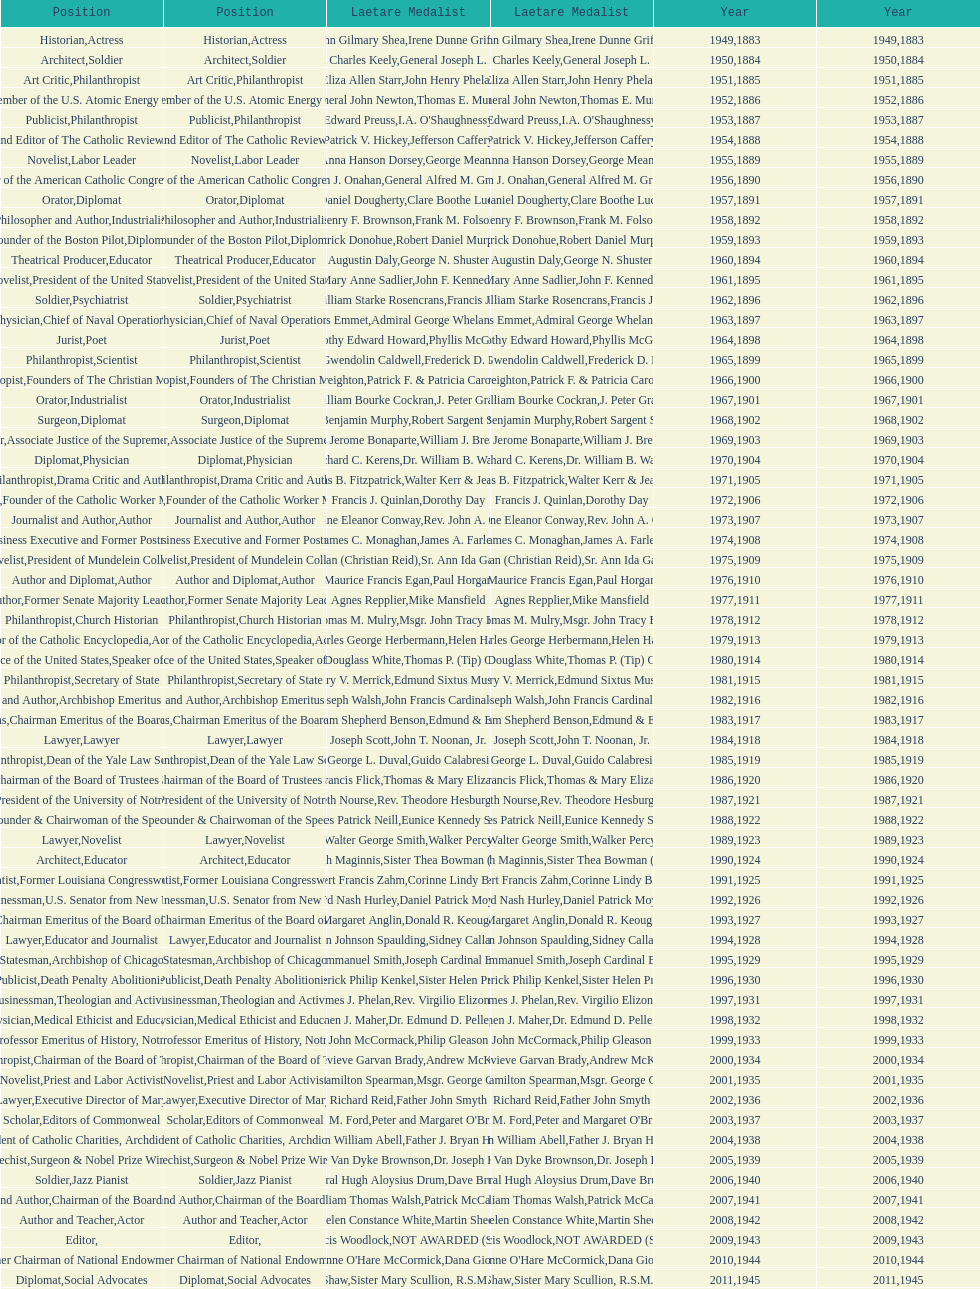How many laetare medalists were philantrohpists? 2. Could you parse the entire table? {'header': ['Position', 'Position', 'Laetare Medalist', 'Laetare Medalist', 'Year', 'Year'], 'rows': [['Historian', 'Actress', 'John Gilmary Shea', 'Irene Dunne Griffin', '1949', '1883'], ['Architect', 'Soldier', 'Patrick Charles Keely', 'General Joseph L. Collins', '1950', '1884'], ['Art Critic', 'Philanthropist', 'Eliza Allen Starr', 'John Henry Phelan', '1951', '1885'], ['Engineer', 'Member of the U.S. Atomic Energy Commission', 'General John Newton', 'Thomas E. Murray', '1952', '1886'], ['Publicist', 'Philanthropist', 'Edward Preuss', "I.A. O'Shaughnessy", '1953', '1887'], ['Founder and Editor of The Catholic Review', 'Diplomat', 'Patrick V. Hickey', 'Jefferson Caffery', '1954', '1888'], ['Novelist', 'Labor Leader', 'Anna Hanson Dorsey', 'George Meany', '1955', '1889'], ['Organizer of the American Catholic Congress', 'Soldier', 'William J. Onahan', 'General Alfred M. Gruenther', '1956', '1890'], ['Orator', 'Diplomat', 'Daniel Dougherty', 'Clare Boothe Luce', '1957', '1891'], ['Philosopher and Author', 'Industrialist', 'Henry F. Brownson', 'Frank M. Folsom', '1958', '1892'], ['Founder of the Boston Pilot', 'Diplomat', 'Patrick Donohue', 'Robert Daniel Murphy', '1959', '1893'], ['Theatrical Producer', 'Educator', 'Augustin Daly', 'George N. Shuster', '1960', '1894'], ['Novelist', 'President of the United States', 'Mary Anne Sadlier', 'John F. Kennedy', '1961', '1895'], ['Soldier', 'Psychiatrist', 'General William Starke Rosencrans', 'Francis J. Braceland', '1962', '1896'], ['Physician', 'Chief of Naval Operations', 'Thomas Addis Emmet', 'Admiral George Whelan Anderson, Jr.', '1963', '1897'], ['Jurist', 'Poet', 'Timothy Edward Howard', 'Phyllis McGinley', '1964', '1898'], ['Philanthropist', 'Scientist', 'Mary Gwendolin Caldwell', 'Frederick D. Rossini', '1965', '1899'], ['Philanthropist', 'Founders of The Christian Movement', 'John A. Creighton', 'Patrick F. & Patricia Caron Crowley', '1966', '1900'], ['Orator', 'Industrialist', 'William Bourke Cockran', 'J. Peter Grace', '1967', '1901'], ['Surgeon', 'Diplomat', 'John Benjamin Murphy', 'Robert Sargent Shriver', '1968', '1902'], ['Lawyer', 'Associate Justice of the Supreme Court', 'Charles Jerome Bonaparte', 'William J. Brennan Jr.', '1969', '1903'], ['Diplomat', 'Physician', 'Richard C. Kerens', 'Dr. William B. Walsh', '1970', '1904'], ['Philanthropist', 'Drama Critic and Author', 'Thomas B. Fitzpatrick', 'Walter Kerr & Jean Kerr', '1971', '1905'], ['Physician', 'Founder of the Catholic Worker Movement', 'Francis J. Quinlan', 'Dorothy Day', '1972', '1906'], ['Journalist and Author', 'Author', 'Katherine Eleanor Conway', "Rev. John A. O'Brien", '1973', '1907'], ['Economist', 'Business Executive and Former Postmaster General', 'James C. Monaghan', 'James A. Farley', '1974', '1908'], ['Novelist', 'President of Mundelein College', 'Frances Tieran (Christian Reid)', 'Sr. Ann Ida Gannon, BMV', '1975', '1909'], ['Author and Diplomat', 'Author', 'Maurice Francis Egan', 'Paul Horgan', '1976', '1910'], ['Author', 'Former Senate Majority Leader', 'Agnes Repplier', 'Mike Mansfield', '1977', '1911'], ['Philanthropist', 'Church Historian', 'Thomas M. Mulry', 'Msgr. John Tracy Ellis', '1978', '1912'], ['Editor of the Catholic Encyclopedia', 'Actress', 'Charles George Herbermann', 'Helen Hayes', '1979', '1913'], ['Chief Justice of the United States', 'Speaker of the House', 'Edward Douglass White', "Thomas P. (Tip) O'Neill Jr.", '1980', '1914'], ['Philanthropist', 'Secretary of State', 'Mary V. Merrick', 'Edmund Sixtus Muskie', '1981', '1915'], ['Physician and Author', 'Archbishop Emeritus of Detroit', 'James Joseph Walsh', 'John Francis Cardinal Dearden', '1982', '1916'], ['Chief of Naval Operations', 'Chairman Emeritus of the Board of Trustees and his wife', 'Admiral William Shepherd Benson', 'Edmund & Evelyn Stephan', '1983', '1917'], ['Lawyer', 'Lawyer', 'Joseph Scott', 'John T. Noonan, Jr.', '1984', '1918'], ['Philanthropist', 'Dean of the Yale Law School', 'George L. Duval', 'Guido Calabresi', '1985', '1919'], ['Physician', 'Chairman of the Board of Trustees and his wife', 'Lawrence Francis Flick', 'Thomas & Mary Elizabeth Carney', '1986', '1920'], ['Artist', 'President of the University of Notre Dame', 'Elizabeth Nourse', 'Rev. Theodore Hesburgh, CSC', '1987', '1921'], ['Economist', 'Founder & Chairwoman of the Special Olympics', 'Charles Patrick Neill', 'Eunice Kennedy Shriver', '1988', '1922'], ['Lawyer', 'Novelist', 'Walter George Smith', 'Walker Percy', '1989', '1923'], ['Architect', 'Educator', 'Charles Donagh Maginnis', 'Sister Thea Bowman (posthumously)', '1990', '1924'], ['Scientist', 'Former Louisiana Congresswoman', 'Albert Francis Zahm', 'Corinne Lindy Boggs', '1991', '1925'], ['Businessman', 'U.S. Senator from New York', 'Edward Nash Hurley', 'Daniel Patrick Moynihan', '1992', '1926'], ['Actress', 'Chairman Emeritus of the Board of Trustees', 'Margaret Anglin', 'Donald R. Keough', '1993', '1927'], ['Lawyer', 'Educator and Journalist', 'John Johnson Spaulding', 'Sidney Callahan', '1994', '1928'], ['Statesman', 'Archbishop of Chicago', 'Alfred Emmanuel Smith', 'Joseph Cardinal Bernardin', '1995', '1929'], ['Publicist', 'Death Penalty Abolitionist', 'Frederick Philip Kenkel', 'Sister Helen Prejean', '1996', '1930'], ['Businessman', 'Theologian and Activist', 'James J. Phelan', 'Rev. Virgilio Elizondo', '1997', '1931'], ['Physician', 'Medical Ethicist and Educator', 'Stephen J. Maher', 'Dr. Edmund D. Pellegrino', '1998', '1932'], ['Artist', 'Professor Emeritus of History, Notre Dame', 'John McCormack', 'Philip Gleason', '1999', '1933'], ['Philanthropist', 'Chairman of the Board of Trustees', 'Genevieve Garvan Brady', 'Andrew McKenna', '2000', '1934'], ['Novelist', 'Priest and Labor Activist', 'Francis Hamilton Spearman', 'Msgr. George G. Higgins', '2001', '1935'], ['Journalist and Lawyer', 'Executive Director of Maryville Academy', 'Richard Reid', 'Father John Smyth', '2002', '1936'], ['Scholar', 'Editors of Commonweal', 'Jeremiah D. M. Ford', "Peter and Margaret O'Brien Steinfels", '2003', '1937'], ['Surgeon', 'President of Catholic Charities, Archdiocese of Boston', 'Irvin William Abell', 'Father J. Bryan Hehir', '2004', '1938'], ['Catechist', 'Surgeon & Nobel Prize Winner', 'Josephine Van Dyke Brownson', 'Dr. Joseph E. Murray', '2005', '1939'], ['Soldier', 'Jazz Pianist', 'General Hugh Aloysius Drum', 'Dave Brubeck', '2006', '1940'], ['Journalist and Author', 'Chairman of the Board of Trustees', 'William Thomas Walsh', 'Patrick McCartan', '2007', '1941'], ['Author and Teacher', 'Actor', 'Helen Constance White', 'Martin Sheen', '2008', '1942'], ['Editor', '', 'Thomas Francis Woodlock', 'NOT AWARDED (SEE BELOW)', '2009', '1943'], ['Journalist', 'Former Chairman of National Endowment for the Arts', "Anne O'Hare McCormick", 'Dana Gioia', '2010', '1944'], ['Diplomat', 'Social Advocates', 'Gardiner Howland Shaw', 'Sister Mary Scullion, R.S.M., & Joan McConnon', '2011', '1945'], ['Historian and Diplomat', 'Former President of Catholic Relief Services', 'Carlton J. H. Hayes', 'Ken Hackett', '2012', '1946'], ['Publisher and Civic Leader', 'Founders of S.P.R.E.D. (Special Religious Education Development Network)', 'William G. Bruce', 'Sister Susanne Gallagher, S.P.\\nSister Mary Therese Harrington, S.H.\\nRev. James H. McCarthy', '2013', '1947'], ['Postmaster General and Civic Leader', 'Professor of Biology at Brown University', 'Frank C. Walker', 'Kenneth R. Miller', '2014', '1948']]} 